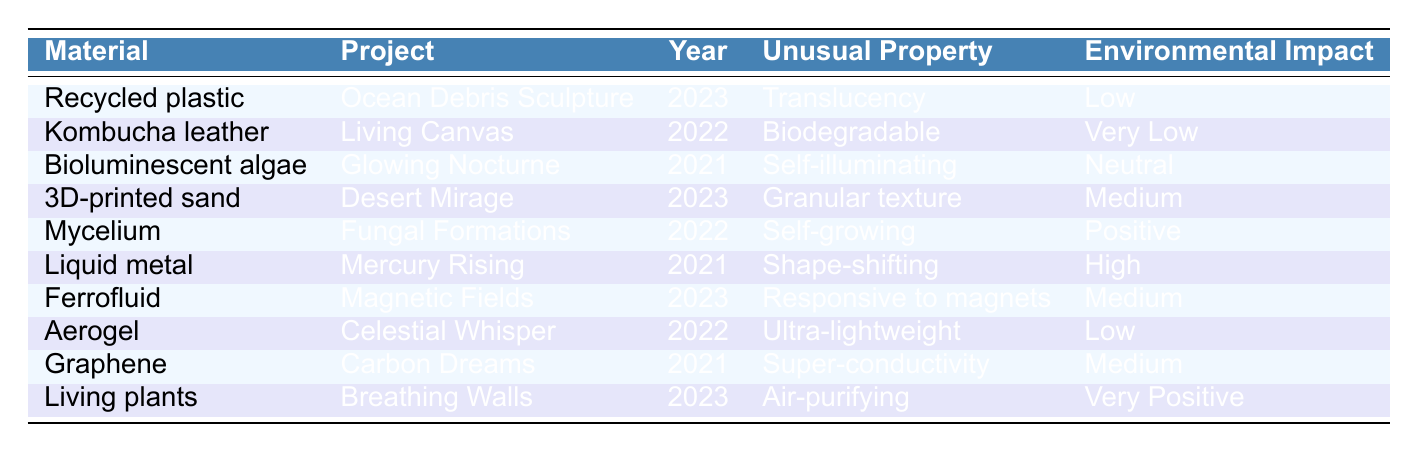What year was the project "Living Canvas" completed? The project "Living Canvas" is listed in the table under the "Project" column, and its corresponding year is in the "Year" column next to it, which is 2022.
Answer: 2022 Which material used in a project has the lowest environmental impact? To find the material with the lowest environmental impact, we look at the "Environmental Impact" column and find that "Kombucha leather" from the project "Living Canvas" has a "Very Low" impact, which is the lowest designation in the table.
Answer: Kombucha leather How many projects used materials categorized as having a "Medium" environmental impact? There are three materials listed under "Environmental Impact" with a "Medium" rating: "3D-printed sand," "Ferrofluid," and "Graphene." Therefore, the count of projects with this rating is three.
Answer: 3 Is "Bioluminescent algae" a self-illuminating material? By examining the "Unusual Property" column for "Bioluminescent algae," it states "Self-illuminating," which confirms that this material indeed has that property.
Answer: Yes What is the average environmental impact rating based on a qualitative scale from Low (1) to High (4)? First, we assign values to each impact rating: Low (1), Very Low (0), Neutral (2), Medium (3), Positive (4), and Very Positive (5). The environmental impacts for all materials are assigned values accordingly and totaled: (1 + 0 + 2 + 3 + 4 + 4 + 3 + 1 + 3 + 5) = 26. The number of projects is 10, so the average is 26/10 = 2.6, which is closer to "Neutral."
Answer: Neutral Who worked with "Fungal Formations"? The project "Fungal Formations" was created using "Mycelium" as a material, which is detailed in the corresponding row of the table.
Answer: Mycelium 